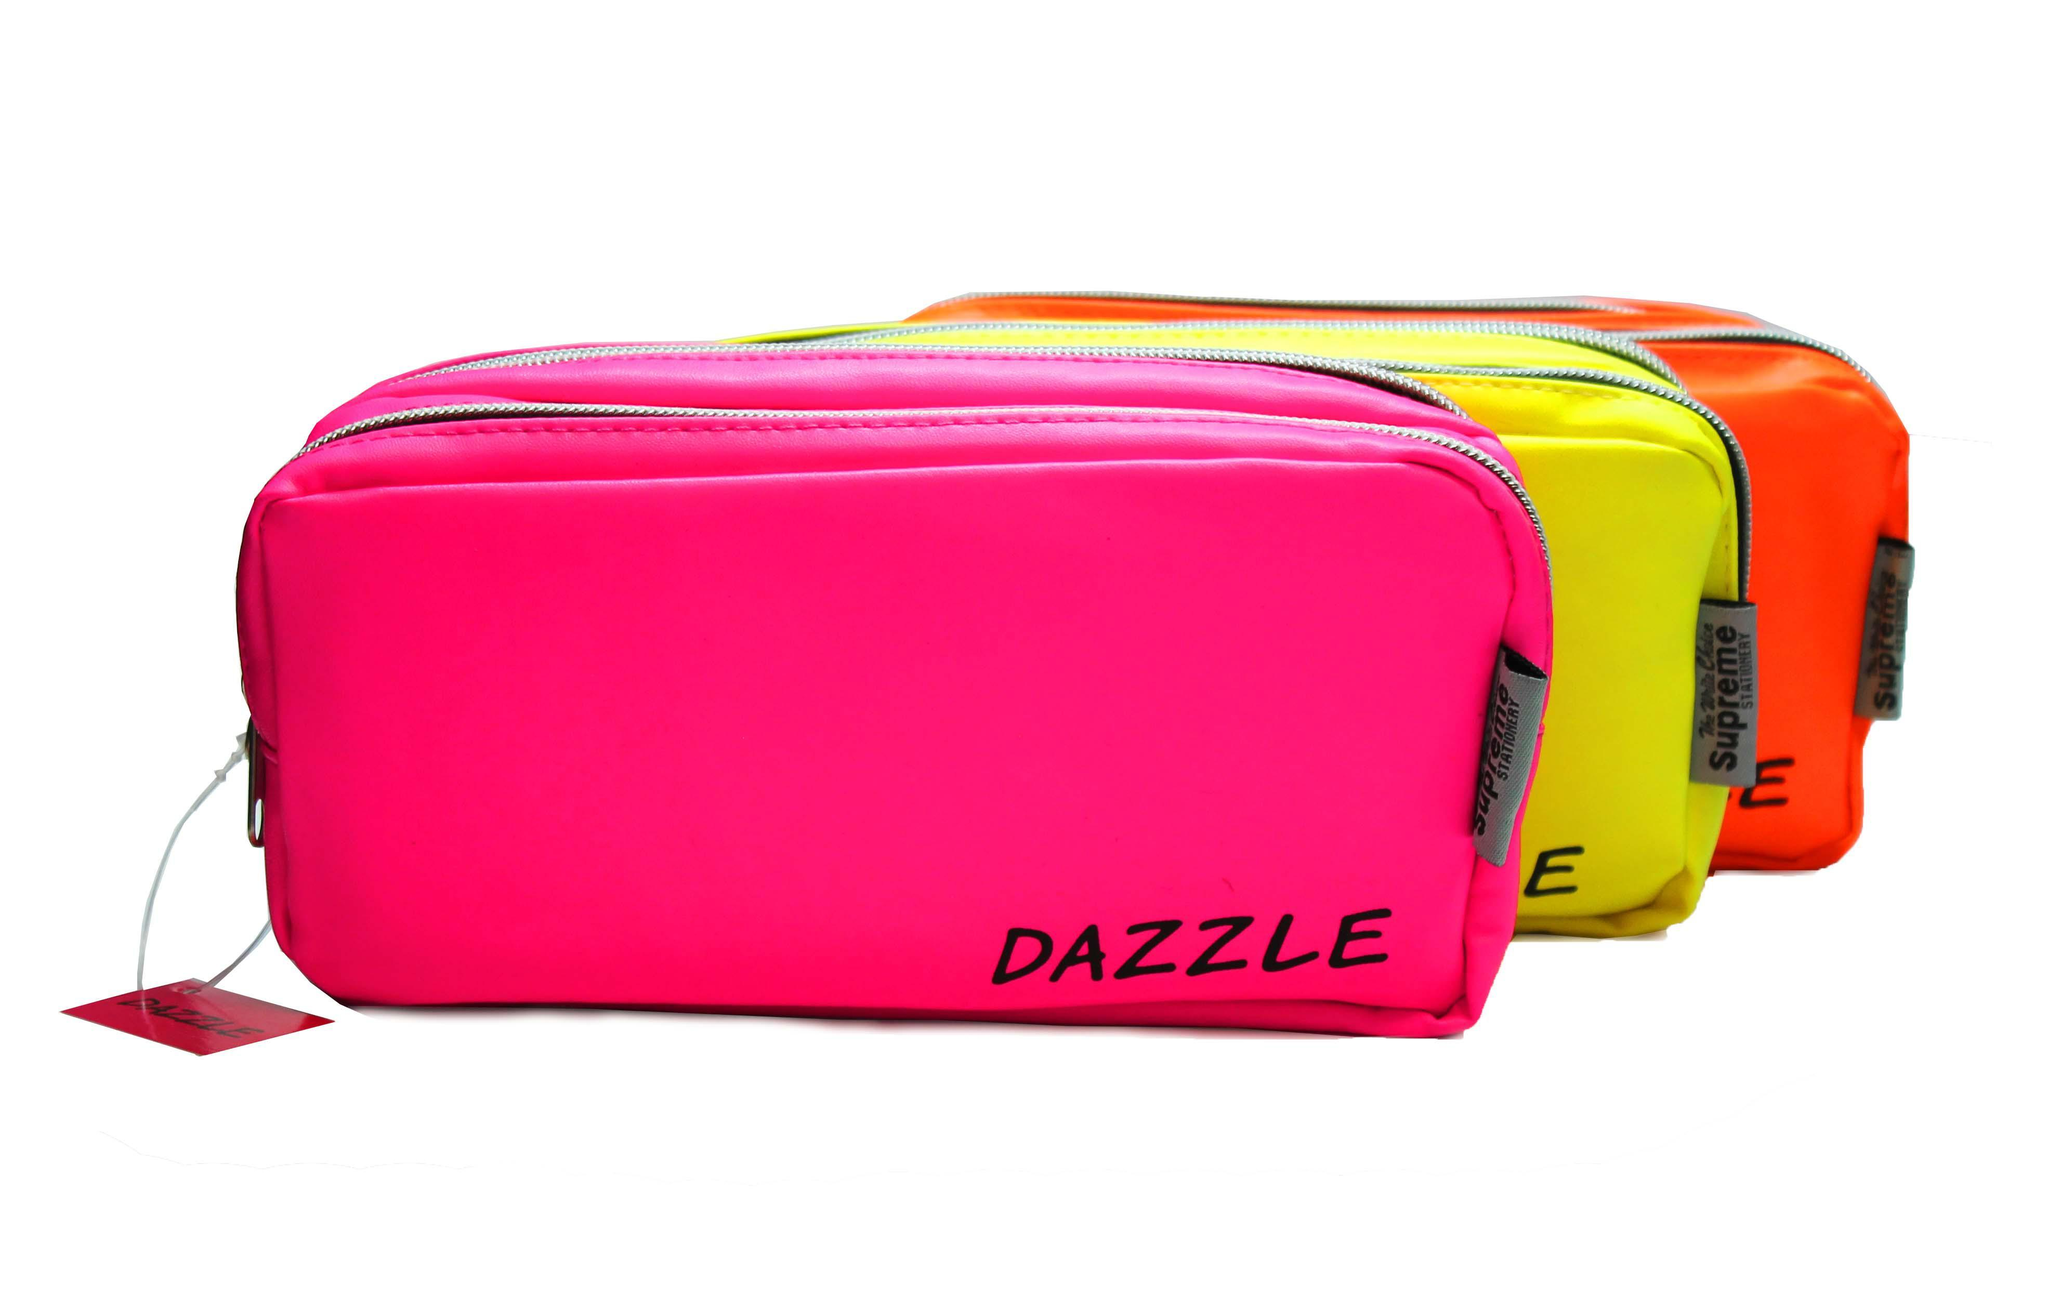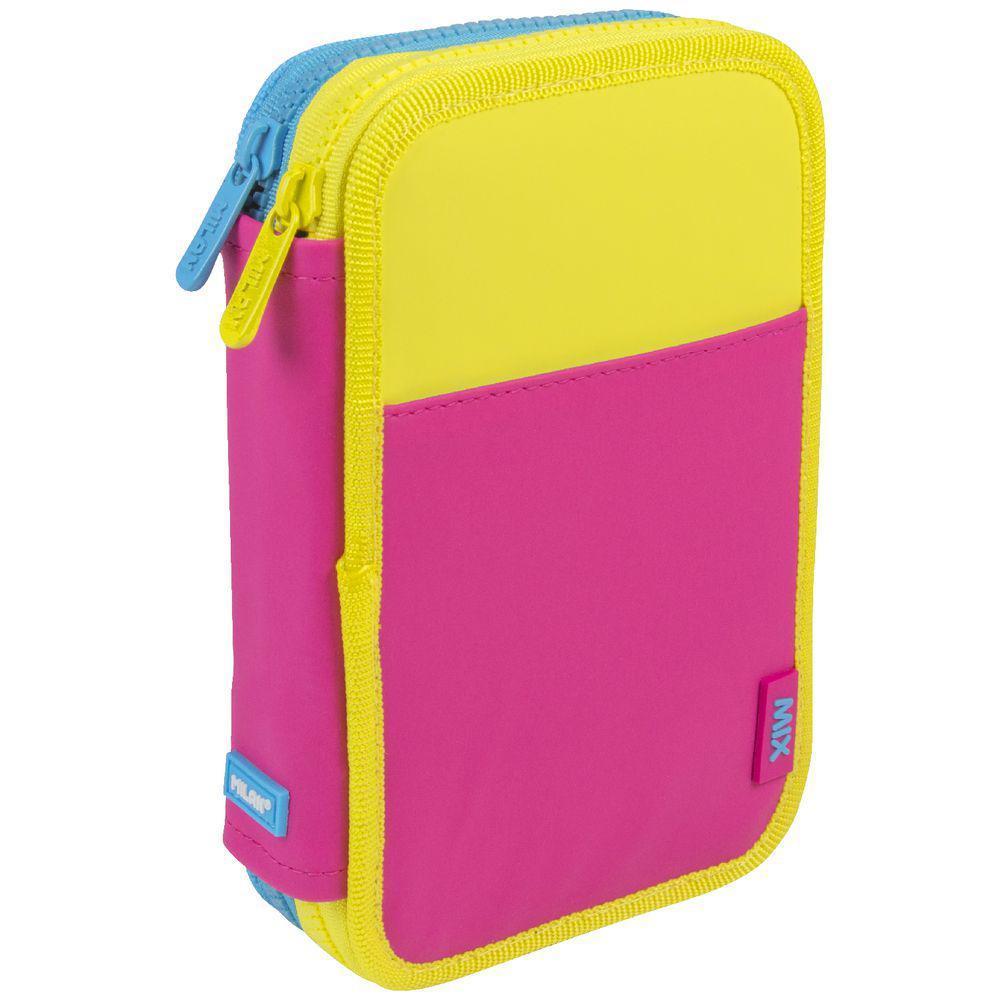The first image is the image on the left, the second image is the image on the right. Analyze the images presented: Is the assertion "In at least one image there is a pencil case with colored stripe patterns on the side of the case." valid? Answer yes or no. No. The first image is the image on the left, the second image is the image on the right. Considering the images on both sides, is "The left image shows an overlapping, upright row of at least three color versions of a pencil case style." valid? Answer yes or no. Yes. 